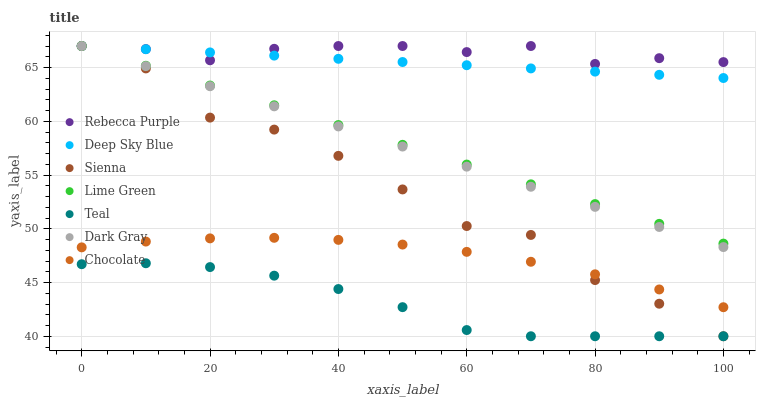Does Teal have the minimum area under the curve?
Answer yes or no. Yes. Does Rebecca Purple have the maximum area under the curve?
Answer yes or no. Yes. Does Deep Sky Blue have the minimum area under the curve?
Answer yes or no. No. Does Deep Sky Blue have the maximum area under the curve?
Answer yes or no. No. Is Dark Gray the smoothest?
Answer yes or no. Yes. Is Sienna the roughest?
Answer yes or no. Yes. Is Deep Sky Blue the smoothest?
Answer yes or no. No. Is Deep Sky Blue the roughest?
Answer yes or no. No. Does Sienna have the lowest value?
Answer yes or no. Yes. Does Deep Sky Blue have the lowest value?
Answer yes or no. No. Does Lime Green have the highest value?
Answer yes or no. Yes. Does Chocolate have the highest value?
Answer yes or no. No. Is Chocolate less than Dark Gray?
Answer yes or no. Yes. Is Deep Sky Blue greater than Chocolate?
Answer yes or no. Yes. Does Rebecca Purple intersect Sienna?
Answer yes or no. Yes. Is Rebecca Purple less than Sienna?
Answer yes or no. No. Is Rebecca Purple greater than Sienna?
Answer yes or no. No. Does Chocolate intersect Dark Gray?
Answer yes or no. No. 